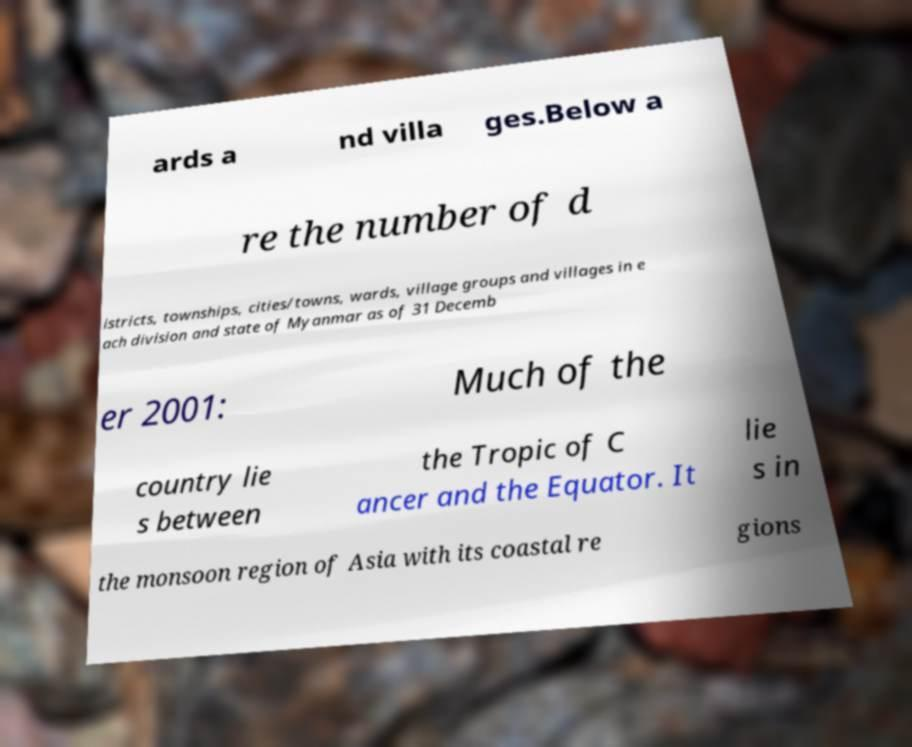There's text embedded in this image that I need extracted. Can you transcribe it verbatim? ards a nd villa ges.Below a re the number of d istricts, townships, cities/towns, wards, village groups and villages in e ach division and state of Myanmar as of 31 Decemb er 2001: Much of the country lie s between the Tropic of C ancer and the Equator. It lie s in the monsoon region of Asia with its coastal re gions 